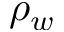Convert formula to latex. <formula><loc_0><loc_0><loc_500><loc_500>\rho _ { w }</formula> 